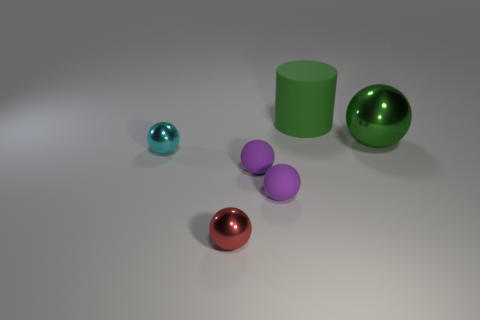Is the color of the shiny thing to the right of the tiny red sphere the same as the matte object that is behind the tiny cyan metal object?
Make the answer very short. Yes. What number of cyan objects have the same shape as the green metal object?
Make the answer very short. 1. What is the color of the big object that is the same shape as the tiny cyan thing?
Keep it short and to the point. Green. There is a large thing that is left of the green sphere; does it have the same color as the big shiny ball?
Keep it short and to the point. Yes. What number of things are metal balls in front of the big ball or rubber cylinders?
Provide a succinct answer. 3. There is a large cylinder behind the cyan metallic sphere in front of the green object that is behind the large green metallic sphere; what is its material?
Keep it short and to the point. Rubber. Is the number of big green objects that are right of the red shiny thing greater than the number of large green spheres that are on the left side of the matte cylinder?
Keep it short and to the point. Yes. How many blocks are either green things or green matte objects?
Keep it short and to the point. 0. What number of matte things are behind the metallic thing that is to the right of the cylinder that is behind the large green metallic object?
Give a very brief answer. 1. There is a large thing that is the same color as the big metal sphere; what material is it?
Give a very brief answer. Rubber. 